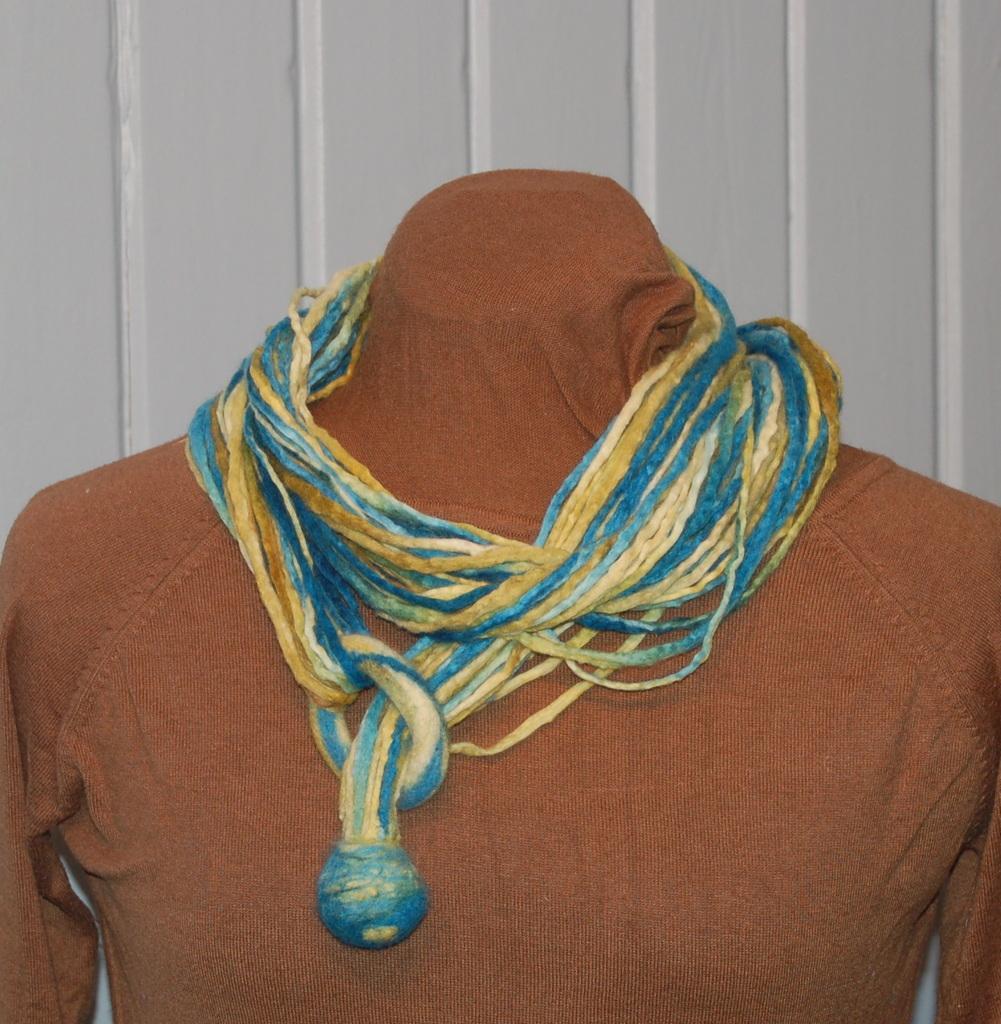How would you summarize this image in a sentence or two? In this image we can see a mannequin with a dress and some threads on it, behind it we can see a wall. 